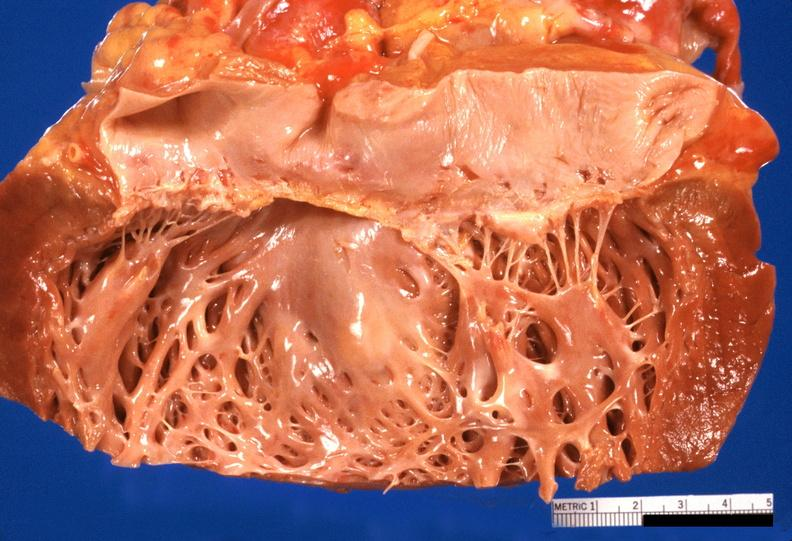s cardiovascular present?
Answer the question using a single word or phrase. Yes 